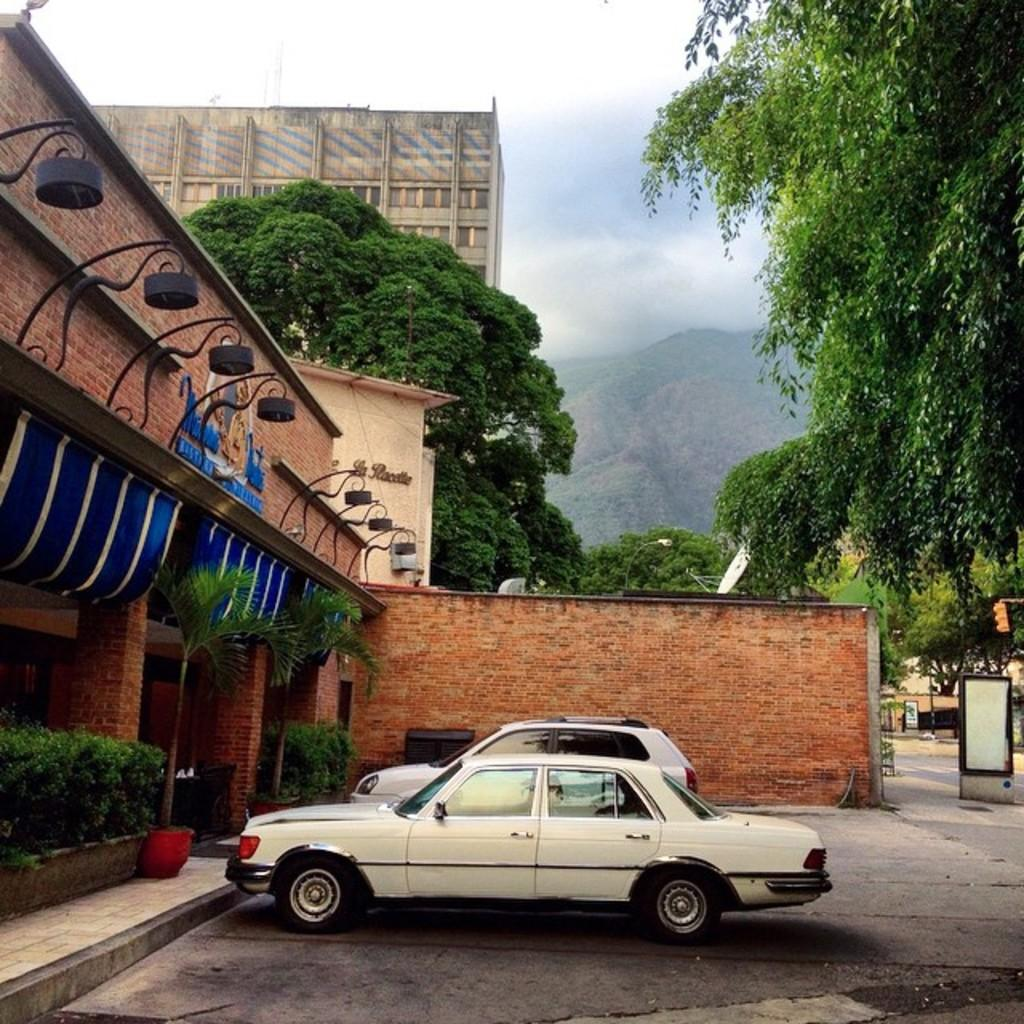What is located in the image that contains plants? There is a flower pot in the image that contains plants. What other types of vegetation can be seen in the image? There are bushes and trees present in the image. What is the setting of the image? The image features a building with two vehicles parked in front, surrounded by vegetation and hills. What is visible at the top of the image? The sky is visible at the top of the image. How many beams are supporting the building in the image? There is no information about beams supporting the building in the image, as the focus is on the vegetation and vehicles. What observation can be made about the riddle hidden in the image? There is no riddle present in the image, as it focuses on the building, vehicles, and surrounding environment. What type of observation can be made about the beam in the image? There is no beam present in the image, so it is not possible to make any observations about it. 